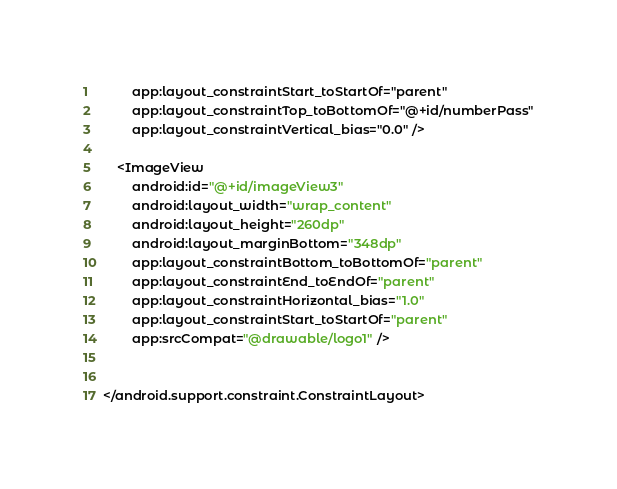Convert code to text. <code><loc_0><loc_0><loc_500><loc_500><_XML_>        app:layout_constraintStart_toStartOf="parent"
        app:layout_constraintTop_toBottomOf="@+id/numberPass"
        app:layout_constraintVertical_bias="0.0" />

    <ImageView
        android:id="@+id/imageView3"
        android:layout_width="wrap_content"
        android:layout_height="260dp"
        android:layout_marginBottom="348dp"
        app:layout_constraintBottom_toBottomOf="parent"
        app:layout_constraintEnd_toEndOf="parent"
        app:layout_constraintHorizontal_bias="1.0"
        app:layout_constraintStart_toStartOf="parent"
        app:srcCompat="@drawable/logo1" />


</android.support.constraint.ConstraintLayout></code> 